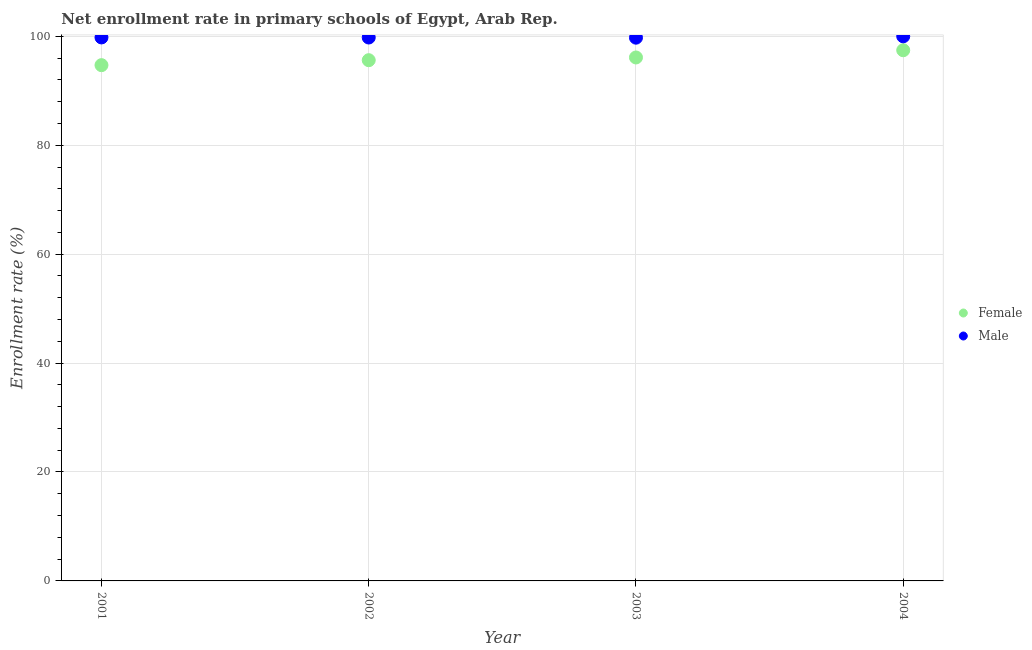What is the enrollment rate of male students in 2003?
Make the answer very short. 99.75. Across all years, what is the maximum enrollment rate of male students?
Provide a short and direct response. 100. Across all years, what is the minimum enrollment rate of male students?
Your response must be concise. 99.75. In which year was the enrollment rate of male students maximum?
Your answer should be very brief. 2004. What is the total enrollment rate of male students in the graph?
Offer a terse response. 399.32. What is the difference between the enrollment rate of female students in 2002 and that in 2004?
Keep it short and to the point. -1.83. What is the difference between the enrollment rate of male students in 2003 and the enrollment rate of female students in 2002?
Keep it short and to the point. 4.13. What is the average enrollment rate of male students per year?
Ensure brevity in your answer.  99.83. In the year 2004, what is the difference between the enrollment rate of female students and enrollment rate of male students?
Make the answer very short. -2.56. What is the ratio of the enrollment rate of female students in 2002 to that in 2003?
Provide a short and direct response. 0.99. Is the enrollment rate of male students in 2001 less than that in 2004?
Provide a succinct answer. Yes. Is the difference between the enrollment rate of female students in 2003 and 2004 greater than the difference between the enrollment rate of male students in 2003 and 2004?
Provide a short and direct response. No. What is the difference between the highest and the second highest enrollment rate of male students?
Keep it short and to the point. 0.21. What is the difference between the highest and the lowest enrollment rate of male students?
Your response must be concise. 0.25. Does the enrollment rate of female students monotonically increase over the years?
Make the answer very short. Yes. Is the enrollment rate of male students strictly greater than the enrollment rate of female students over the years?
Offer a terse response. Yes. Is the enrollment rate of male students strictly less than the enrollment rate of female students over the years?
Keep it short and to the point. No. What is the difference between two consecutive major ticks on the Y-axis?
Ensure brevity in your answer.  20. Are the values on the major ticks of Y-axis written in scientific E-notation?
Offer a terse response. No. Does the graph contain grids?
Your answer should be compact. Yes. Where does the legend appear in the graph?
Your response must be concise. Center right. How are the legend labels stacked?
Offer a very short reply. Vertical. What is the title of the graph?
Offer a terse response. Net enrollment rate in primary schools of Egypt, Arab Rep. Does "Secondary school" appear as one of the legend labels in the graph?
Your answer should be very brief. No. What is the label or title of the Y-axis?
Your answer should be very brief. Enrollment rate (%). What is the Enrollment rate (%) in Female in 2001?
Keep it short and to the point. 94.7. What is the Enrollment rate (%) in Male in 2001?
Your answer should be very brief. 99.79. What is the Enrollment rate (%) of Female in 2002?
Your answer should be very brief. 95.62. What is the Enrollment rate (%) of Male in 2002?
Offer a very short reply. 99.78. What is the Enrollment rate (%) in Female in 2003?
Keep it short and to the point. 96.12. What is the Enrollment rate (%) in Male in 2003?
Provide a succinct answer. 99.75. What is the Enrollment rate (%) of Female in 2004?
Provide a succinct answer. 97.44. What is the Enrollment rate (%) of Male in 2004?
Provide a short and direct response. 100. Across all years, what is the maximum Enrollment rate (%) in Female?
Make the answer very short. 97.44. Across all years, what is the maximum Enrollment rate (%) of Male?
Your response must be concise. 100. Across all years, what is the minimum Enrollment rate (%) in Female?
Give a very brief answer. 94.7. Across all years, what is the minimum Enrollment rate (%) of Male?
Offer a very short reply. 99.75. What is the total Enrollment rate (%) in Female in the graph?
Keep it short and to the point. 383.88. What is the total Enrollment rate (%) in Male in the graph?
Your answer should be very brief. 399.32. What is the difference between the Enrollment rate (%) of Female in 2001 and that in 2002?
Make the answer very short. -0.91. What is the difference between the Enrollment rate (%) in Male in 2001 and that in 2002?
Your answer should be very brief. 0.01. What is the difference between the Enrollment rate (%) in Female in 2001 and that in 2003?
Keep it short and to the point. -1.41. What is the difference between the Enrollment rate (%) of Male in 2001 and that in 2003?
Offer a terse response. 0.04. What is the difference between the Enrollment rate (%) in Female in 2001 and that in 2004?
Provide a short and direct response. -2.74. What is the difference between the Enrollment rate (%) in Male in 2001 and that in 2004?
Your answer should be very brief. -0.21. What is the difference between the Enrollment rate (%) of Female in 2002 and that in 2003?
Your answer should be very brief. -0.5. What is the difference between the Enrollment rate (%) of Male in 2002 and that in 2003?
Your answer should be compact. 0.03. What is the difference between the Enrollment rate (%) of Female in 2002 and that in 2004?
Provide a short and direct response. -1.83. What is the difference between the Enrollment rate (%) of Male in 2002 and that in 2004?
Provide a succinct answer. -0.22. What is the difference between the Enrollment rate (%) in Female in 2003 and that in 2004?
Your answer should be compact. -1.33. What is the difference between the Enrollment rate (%) of Male in 2003 and that in 2004?
Offer a very short reply. -0.25. What is the difference between the Enrollment rate (%) in Female in 2001 and the Enrollment rate (%) in Male in 2002?
Provide a succinct answer. -5.08. What is the difference between the Enrollment rate (%) of Female in 2001 and the Enrollment rate (%) of Male in 2003?
Offer a terse response. -5.05. What is the difference between the Enrollment rate (%) of Female in 2001 and the Enrollment rate (%) of Male in 2004?
Ensure brevity in your answer.  -5.29. What is the difference between the Enrollment rate (%) in Female in 2002 and the Enrollment rate (%) in Male in 2003?
Give a very brief answer. -4.13. What is the difference between the Enrollment rate (%) in Female in 2002 and the Enrollment rate (%) in Male in 2004?
Ensure brevity in your answer.  -4.38. What is the difference between the Enrollment rate (%) in Female in 2003 and the Enrollment rate (%) in Male in 2004?
Provide a succinct answer. -3.88. What is the average Enrollment rate (%) in Female per year?
Provide a succinct answer. 95.97. What is the average Enrollment rate (%) of Male per year?
Give a very brief answer. 99.83. In the year 2001, what is the difference between the Enrollment rate (%) of Female and Enrollment rate (%) of Male?
Offer a very short reply. -5.09. In the year 2002, what is the difference between the Enrollment rate (%) of Female and Enrollment rate (%) of Male?
Provide a short and direct response. -4.16. In the year 2003, what is the difference between the Enrollment rate (%) in Female and Enrollment rate (%) in Male?
Ensure brevity in your answer.  -3.63. In the year 2004, what is the difference between the Enrollment rate (%) of Female and Enrollment rate (%) of Male?
Your response must be concise. -2.56. What is the ratio of the Enrollment rate (%) of Female in 2001 to that in 2002?
Offer a very short reply. 0.99. What is the ratio of the Enrollment rate (%) in Male in 2001 to that in 2002?
Offer a very short reply. 1. What is the ratio of the Enrollment rate (%) of Female in 2001 to that in 2003?
Ensure brevity in your answer.  0.99. What is the ratio of the Enrollment rate (%) in Female in 2001 to that in 2004?
Offer a very short reply. 0.97. What is the ratio of the Enrollment rate (%) of Male in 2001 to that in 2004?
Provide a succinct answer. 1. What is the ratio of the Enrollment rate (%) of Female in 2002 to that in 2004?
Provide a short and direct response. 0.98. What is the ratio of the Enrollment rate (%) in Female in 2003 to that in 2004?
Your answer should be very brief. 0.99. What is the ratio of the Enrollment rate (%) of Male in 2003 to that in 2004?
Your response must be concise. 1. What is the difference between the highest and the second highest Enrollment rate (%) of Female?
Provide a succinct answer. 1.33. What is the difference between the highest and the second highest Enrollment rate (%) of Male?
Give a very brief answer. 0.21. What is the difference between the highest and the lowest Enrollment rate (%) in Female?
Offer a terse response. 2.74. What is the difference between the highest and the lowest Enrollment rate (%) of Male?
Make the answer very short. 0.25. 